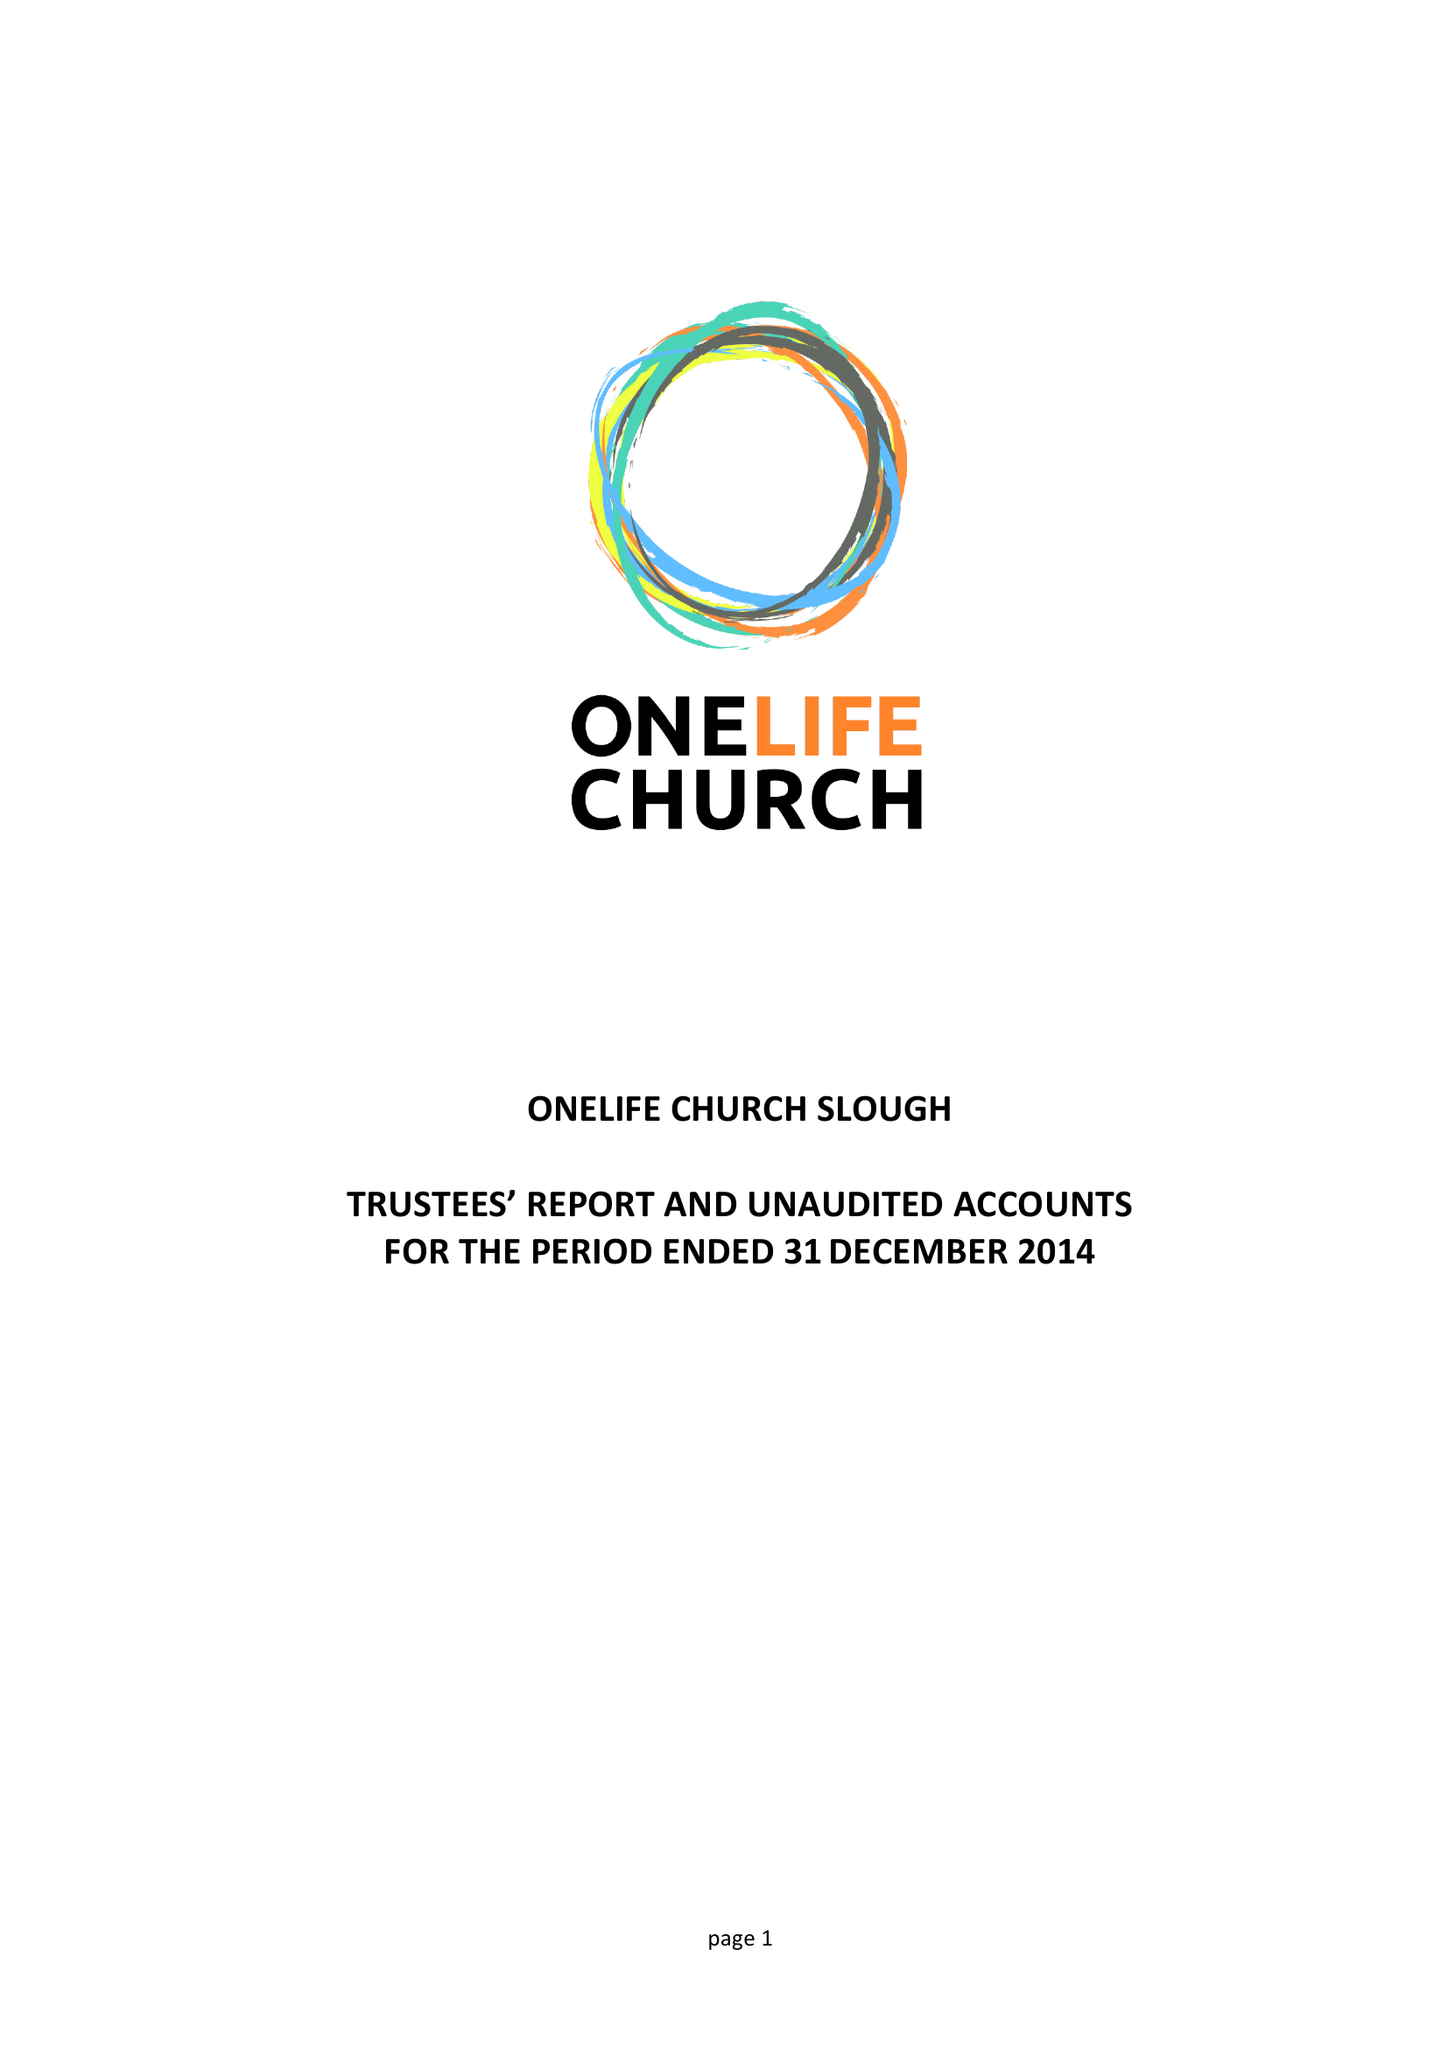What is the value for the address__street_line?
Answer the question using a single word or phrase. 306 SCAFELL ROAD 